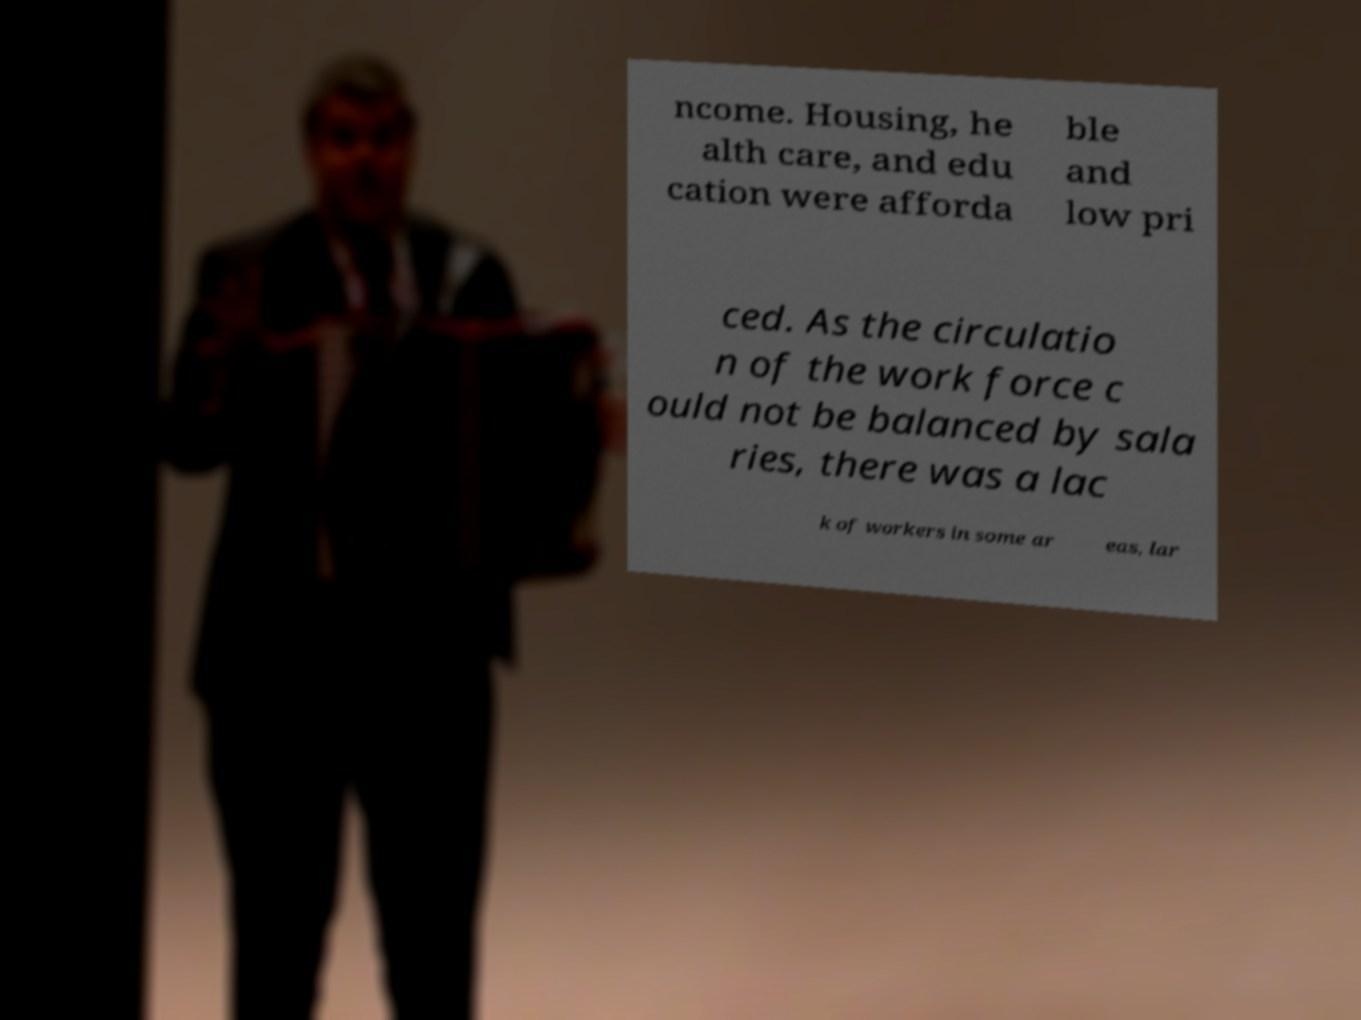Can you accurately transcribe the text from the provided image for me? ncome. Housing, he alth care, and edu cation were afforda ble and low pri ced. As the circulatio n of the work force c ould not be balanced by sala ries, there was a lac k of workers in some ar eas, lar 